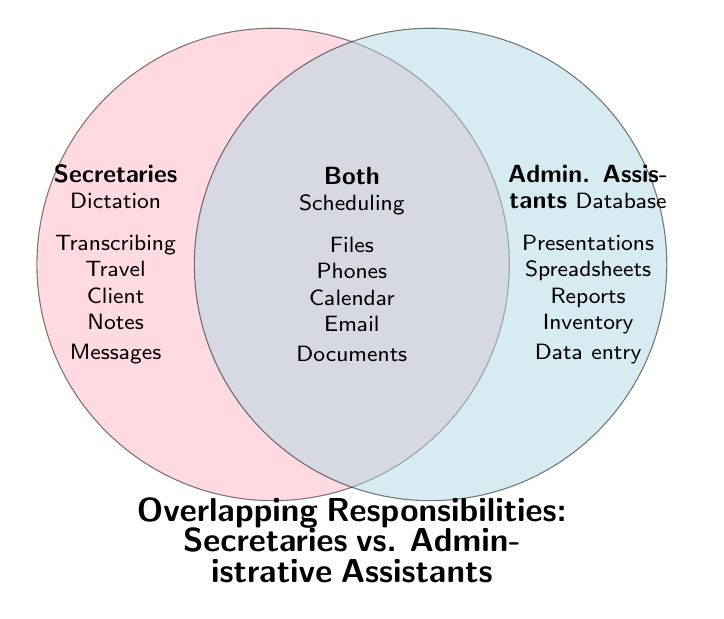What is the title of the figure? The title is located at the bottom of the Venn Diagram and explicitly describes the content. It is written in large, bold letters.
Answer: Overlapping Responsibilities: Secretaries vs. Administrative Assistants Name one area of overlap in responsibilities between secretaries and administrative assistants. The overlap section is labeled "Both," situated where the two circles intersect. One of the tasks listed here is "Scheduling meetings."
Answer: Scheduling meetings How many unique tasks do secretaries have that are not shared with administrative assistants? The tasks unique to secretaries are listed in the left circle only. Counting these, we have Dictation, Transcribing, Travel arrangements, Client correspondence, Note-taking, and Message relay.
Answer: 6 Which group has more unique responsibilities, secretaries or administrative assistants? Count the unique responsibilities for each group. Secretaries have 6 unique tasks, while administrative assistants have 6 unique tasks listed.
Answer: Equal What tasks do administrative assistants and secretaries both handle related to communication? Look in the "Both" section for communication-related tasks. From the listed tasks: Answering phones, Email management, and Document preparation.
Answer: Answering phones, Email management, Document preparation What shared tasks involve managing schedules and organizational tools? Focus on scheduling and organizing-related tasks in the "Both" section. The tasks are Scheduling meetings, Organizing files, Calendar management.
Answer: Scheduling meetings, Organizing files, Calendar management Are there any responsibilities related to inventory management? If so, which group handles it? Scan each section for inventory-related tasks. Office supply inventory is under the Administrative Assistants section.
Answer: Administrative assistants Which role involves tasks related to database and data analysis? Look for database and data-related tasks specifically. These are listed under the Administrative Assistants section as Database management and Spreadsheet analysis.
Answer: Administrative assistants How many total responsibilities are listed for both secretaries and administrative assistants combined including shared and unique tasks? Count each task listed separately in the Secretaries, Both, and Administrative Assistants sections. Secretaries (6) + Both (6) + Administrative Assistants (6).
Answer: 18 Which tasks specific to secretaries involve documentation? Identify documentation-related tasks listed specifically under Secretaries. Relevant tasks are Dictation, Transcribing, and Note-taking.
Answer: Dictation, Transcribing, Note-taking 